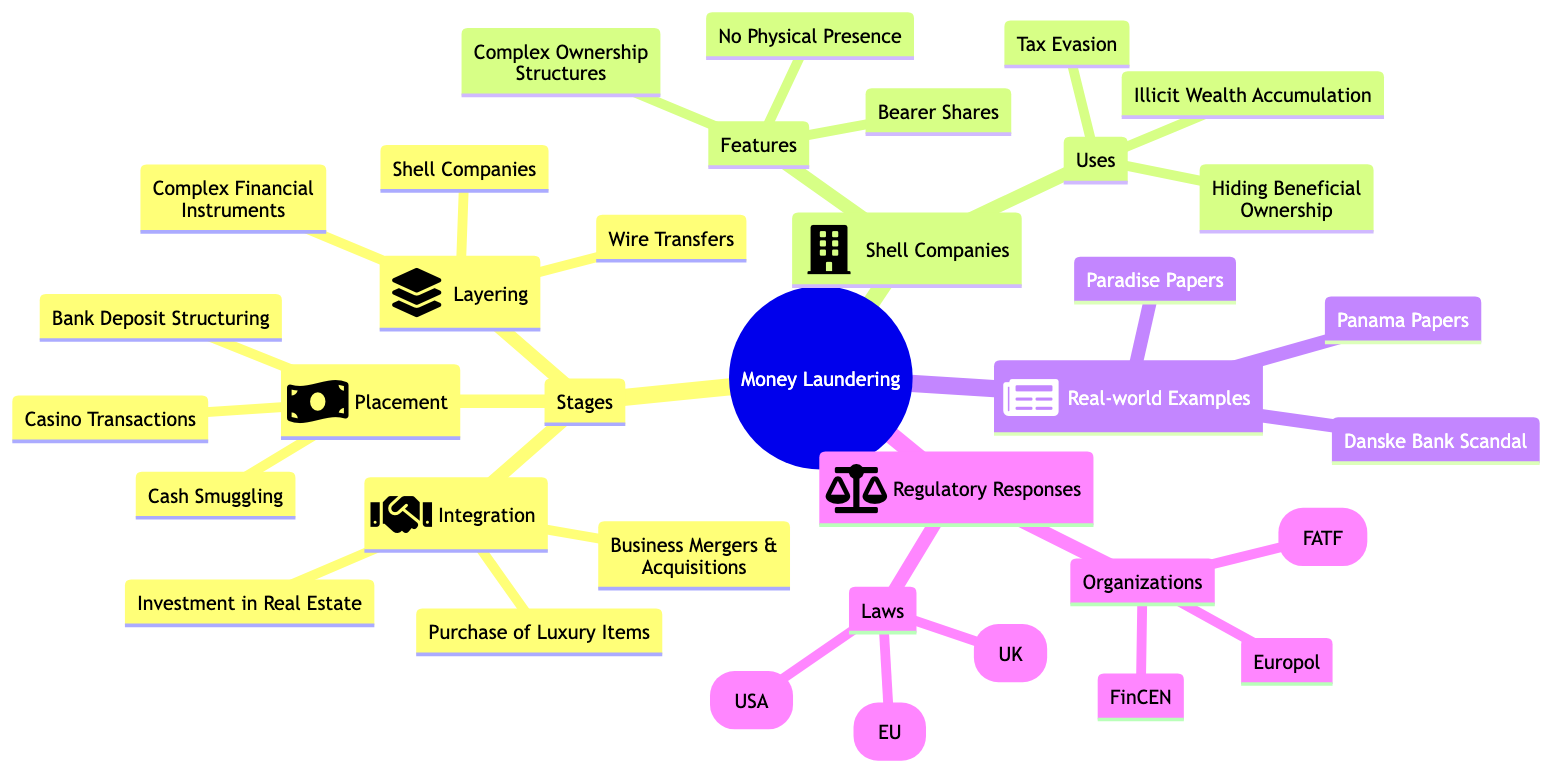What are the three stages of money laundering? The diagram lists the stages of money laundering: Placement, Layering, and Integration. This is identified under the "Stages" section of the "Money Laundering" node.
Answer: Placement, Layering, Integration How many methods are listed under Placement? The “Placement” node specifies three methods used in the placement stage: Cash Smuggling, Bank Deposit Structuring, and Casino Transactions. The total count of these methods provides the answer.
Answer: 3 What is a common use of shell companies? The "Shell Companies" node includes various uses, among which "Tax Evasion" is explicitly mentioned as a noteworthy use.
Answer: Tax Evasion Which organization is part of the regulatory response? The "Regulatory Responses" section lists three organizations, one of which is the "Financial Action Task Force (FATF)." This is a direct reference found in the diagram.
Answer: Financial Action Task Force (FATF) What is the first method under the Layering stage? In the Layering stage, the methods listed begin with "Wire Transfers," specifically the first entry under that section. This direct correlation is evident from the diagram's structure.
Answer: Wire Transfers List one real-world example of money laundering. Under "Real-world Examples," the diagram provides three notable cases, one of which is "Panama Papers." This serves as a specific instance of money laundering cases mentioned.
Answer: Panama Papers What is a feature of shell companies? According to the "Shell Companies" node, one listed feature is "No Physical Presence." This identifies a characteristic trait attributed to shell companies in the diagram.
Answer: No Physical Presence How many laws are mentioned in the regulatory responses? The "Regulatory Responses" node specifies three laws: Bank Secrecy Act (USA), Anti-Money Laundering Directive (EU), and Proceeds of Crime Act (UK). Hence, counting these gives the answer.
Answer: 3 What is the purpose of layering in money laundering? Layering involves tactics to obscure the origins of illicit funds, specifically mentioned in the diagram through techniques like wire transfers and shell companies. Thus, the goal can be inferred from these methods.
Answer: Obscure origins of illicit funds 